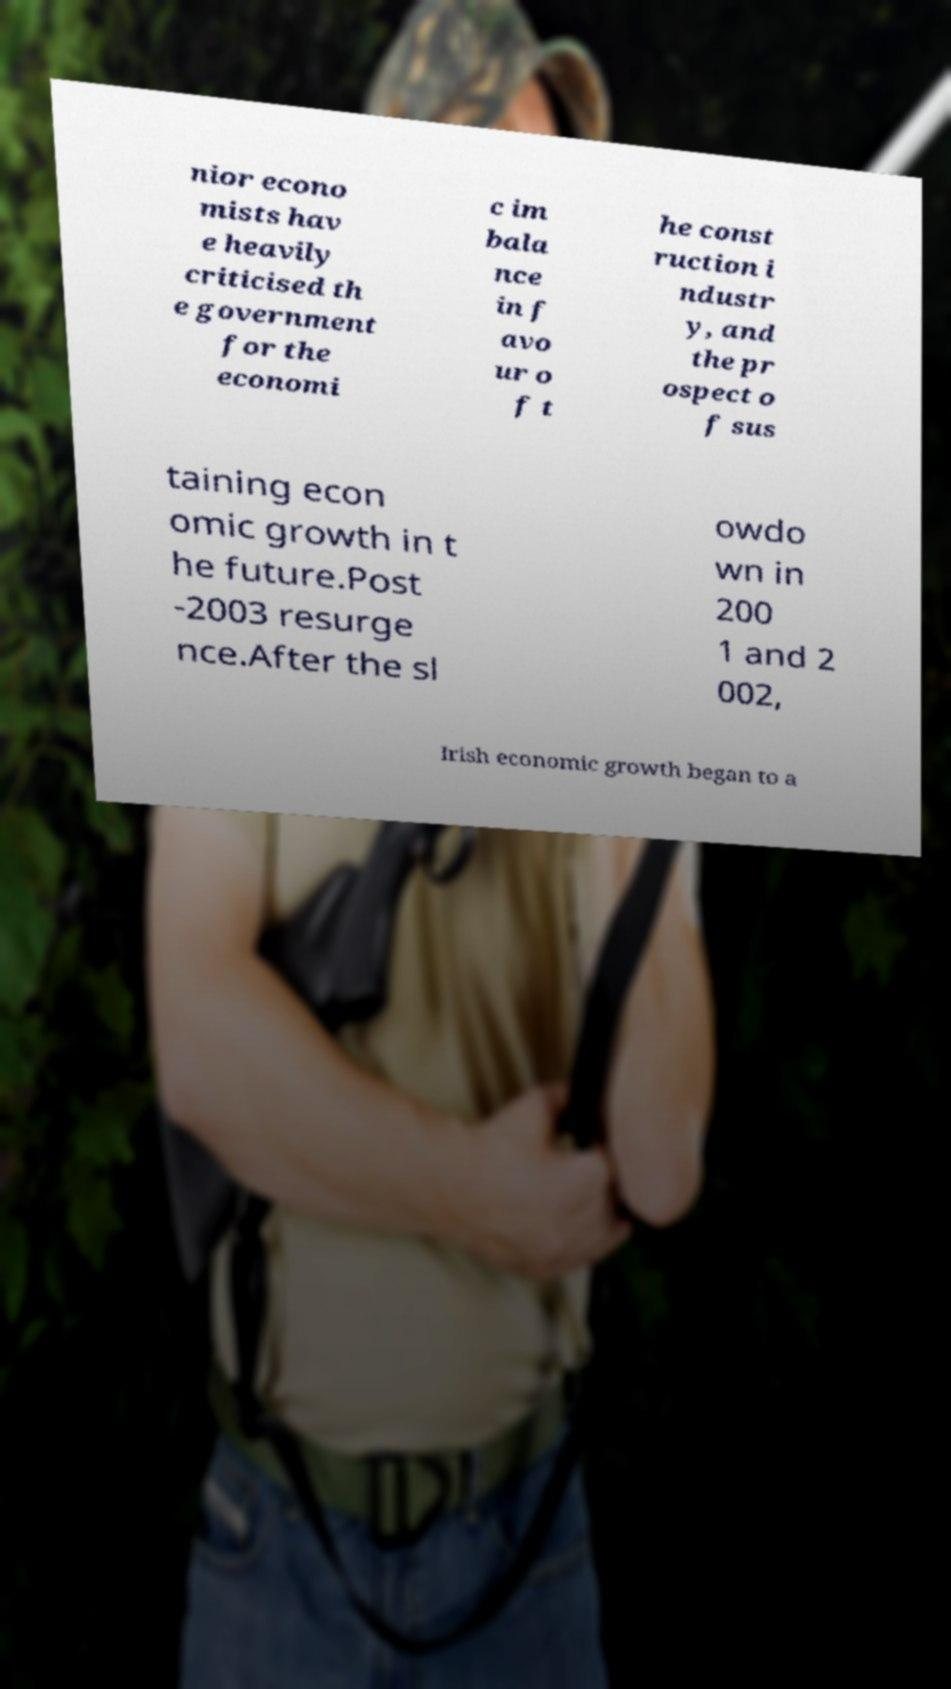There's text embedded in this image that I need extracted. Can you transcribe it verbatim? nior econo mists hav e heavily criticised th e government for the economi c im bala nce in f avo ur o f t he const ruction i ndustr y, and the pr ospect o f sus taining econ omic growth in t he future.Post -2003 resurge nce.After the sl owdo wn in 200 1 and 2 002, Irish economic growth began to a 